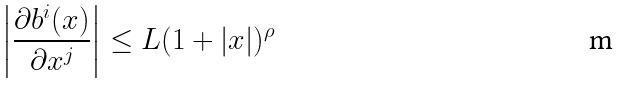<formula> <loc_0><loc_0><loc_500><loc_500>\left | \frac { \partial b ^ { i } ( x ) } { \partial x ^ { j } } \right | & \leq L ( 1 + | x | ) ^ { \rho }</formula> 